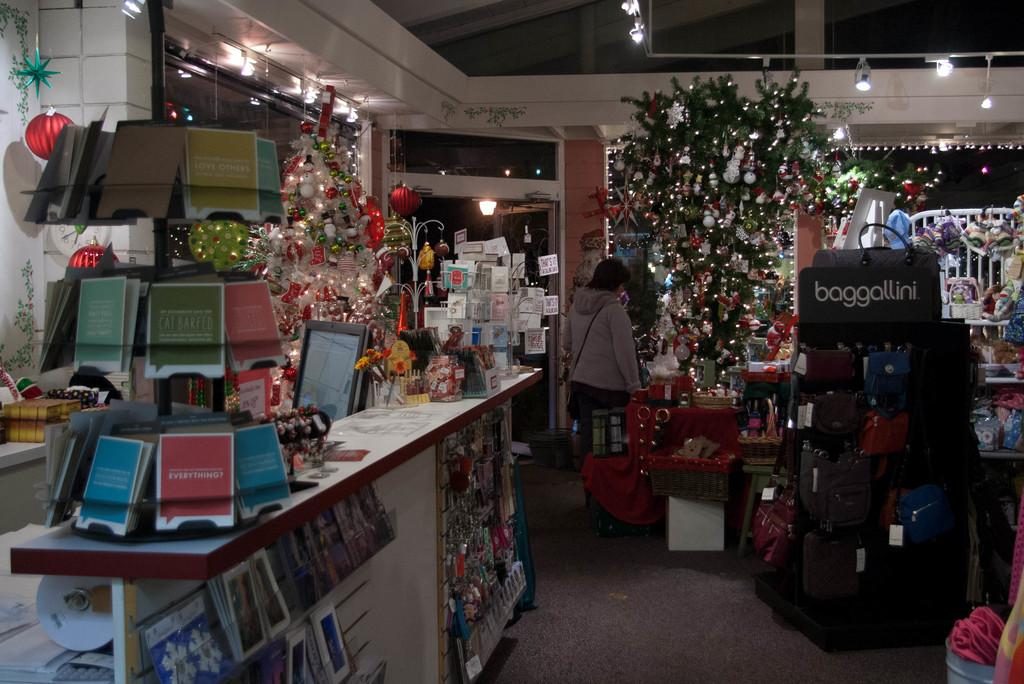<image>
Create a compact narrative representing the image presented. The interior of a store that sells Baggallini bags along with many other items. 